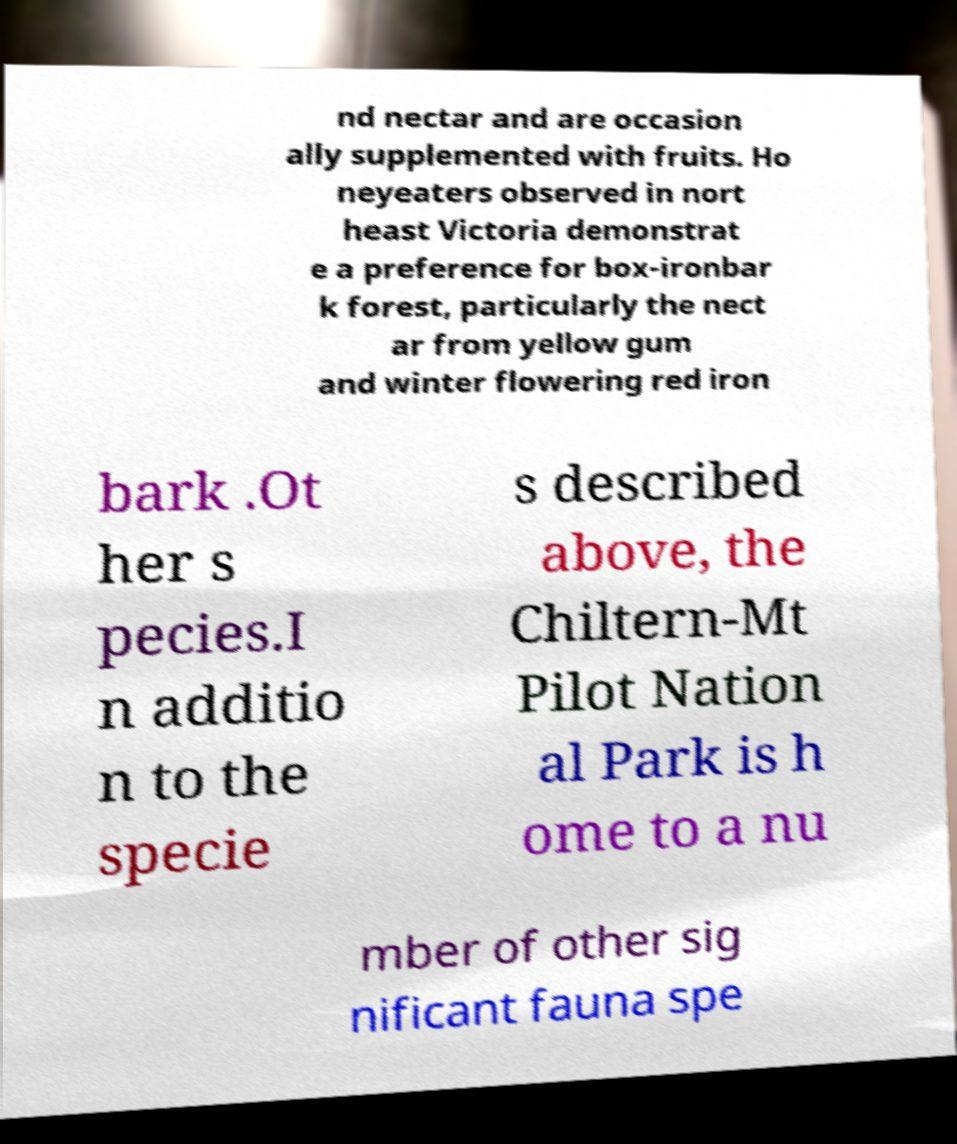For documentation purposes, I need the text within this image transcribed. Could you provide that? nd nectar and are occasion ally supplemented with fruits. Ho neyeaters observed in nort heast Victoria demonstrat e a preference for box-ironbar k forest, particularly the nect ar from yellow gum and winter flowering red iron bark .Ot her s pecies.I n additio n to the specie s described above, the Chiltern-Mt Pilot Nation al Park is h ome to a nu mber of other sig nificant fauna spe 